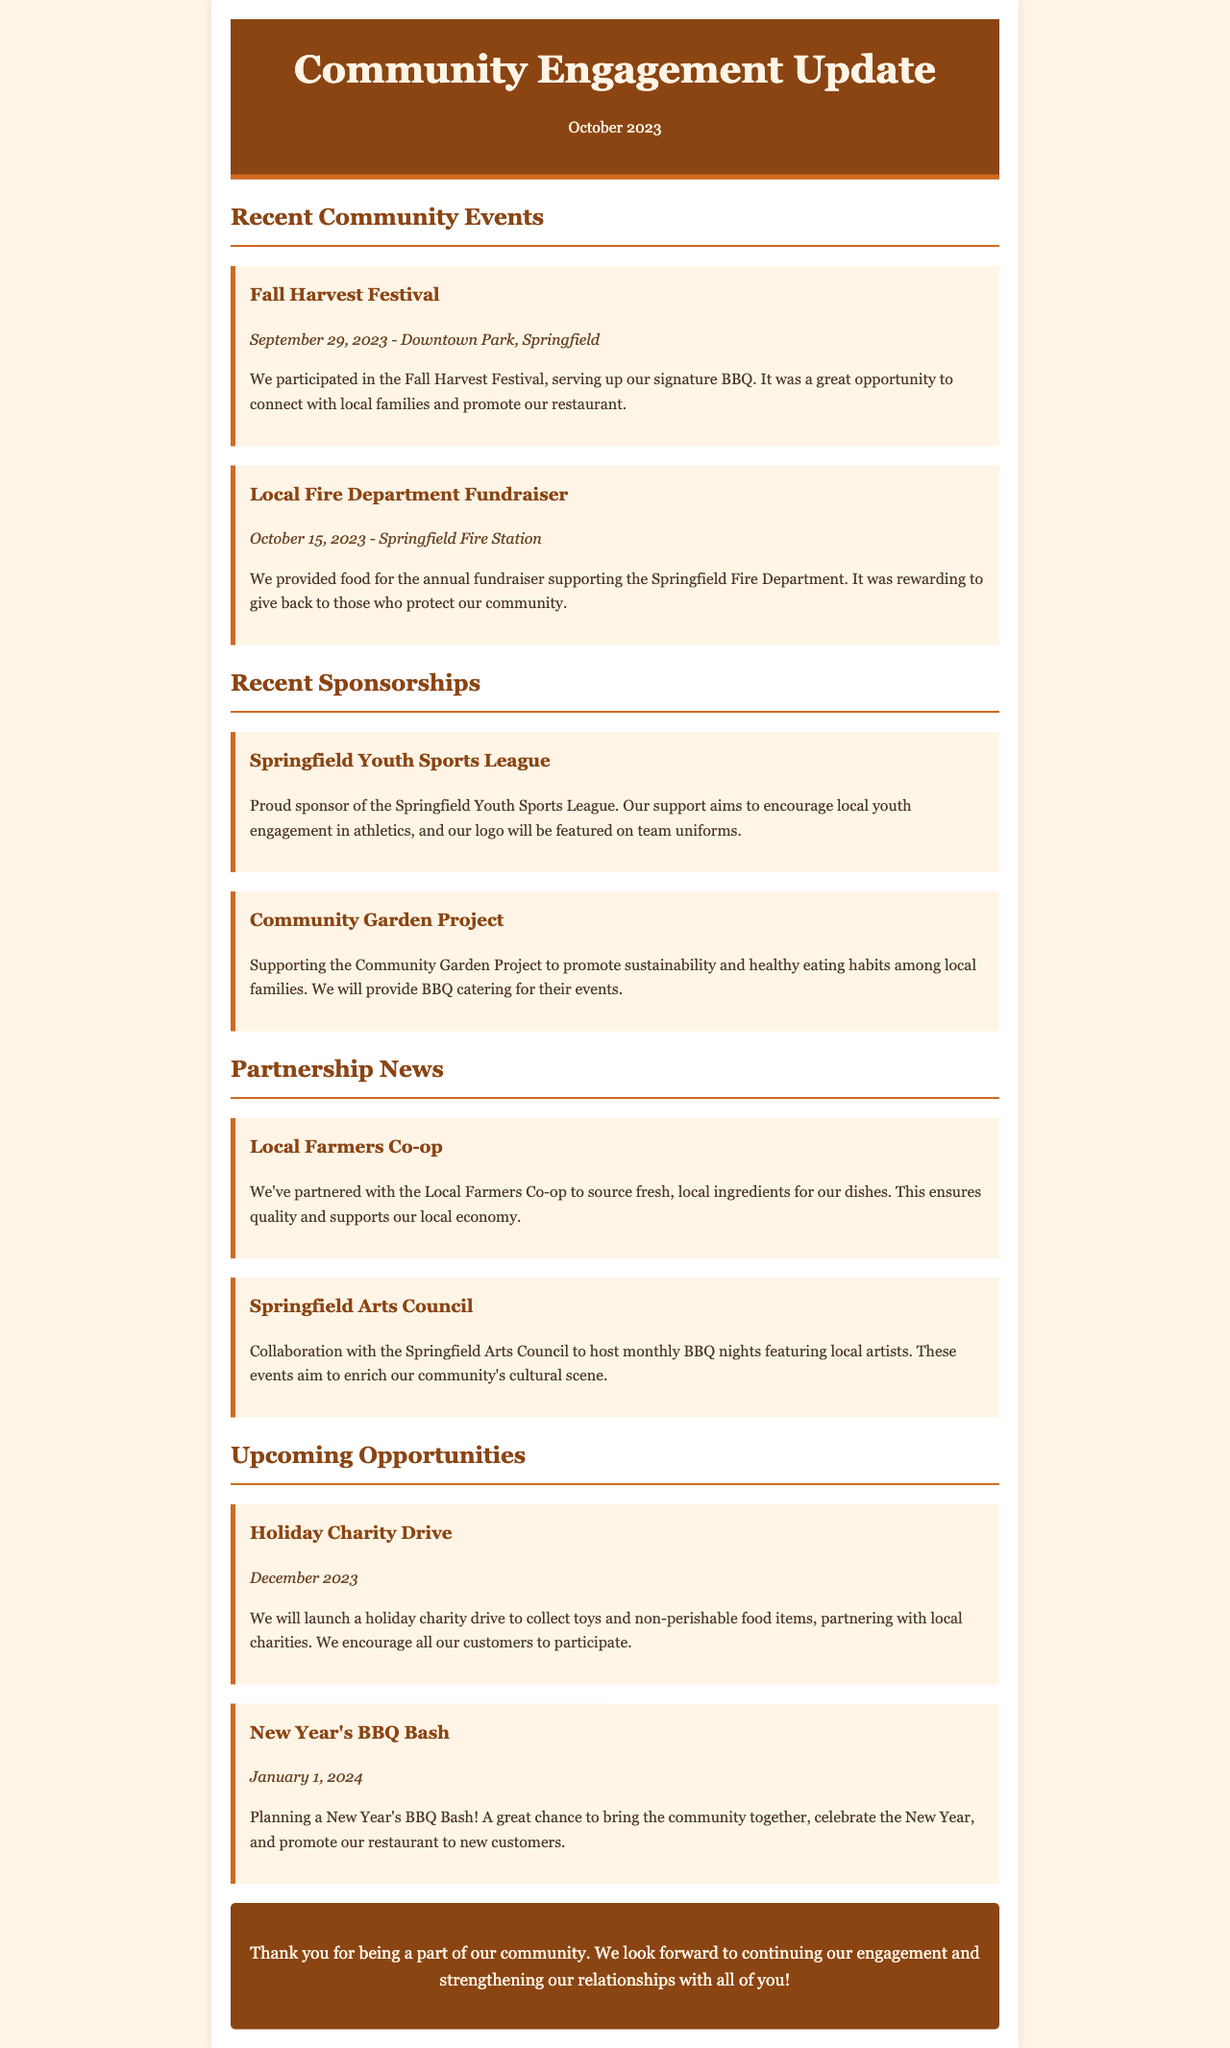What was the date of the Fall Harvest Festival? The date of the Fall Harvest Festival is specifically mentioned as September 29, 2023.
Answer: September 29, 2023 Who did the restaurant support with the recent fundraiser? The restaurant provided food for the annual fundraiser supporting the Springfield Fire Department.
Answer: Springfield Fire Department What is the name of the charity drive planned for December? The charity drive planned for December is specifically referred to as the Holiday Charity Drive.
Answer: Holiday Charity Drive Which local organization is featured as a new sponsorship? The restaurant is a proud sponsor of the Springfield Youth Sports League.
Answer: Springfield Youth Sports League What event is planned for January 1, 2024? The event planned for January 1, 2024, is titled New Year's BBQ Bash.
Answer: New Year's BBQ Bash What initiative is taken to promote healthy eating habits? The restaurant supports the Community Garden Project to promote sustainability and healthy eating habits among local families.
Answer: Community Garden Project How has the restaurant engaged with local artists? The collaboration with the Springfield Arts Council hosts monthly BBQ nights featuring local artists.
Answer: Monthly BBQ nights What month is the Holiday Charity Drive scheduled for? The Holiday Charity Drive is scheduled for December 2023.
Answer: December 2023 Which two local initiatives does the restaurant mention in partnership news? The document mentions the Local Farmers Co-op and the Springfield Arts Council in partnership news.
Answer: Local Farmers Co-op, Springfield Arts Council 